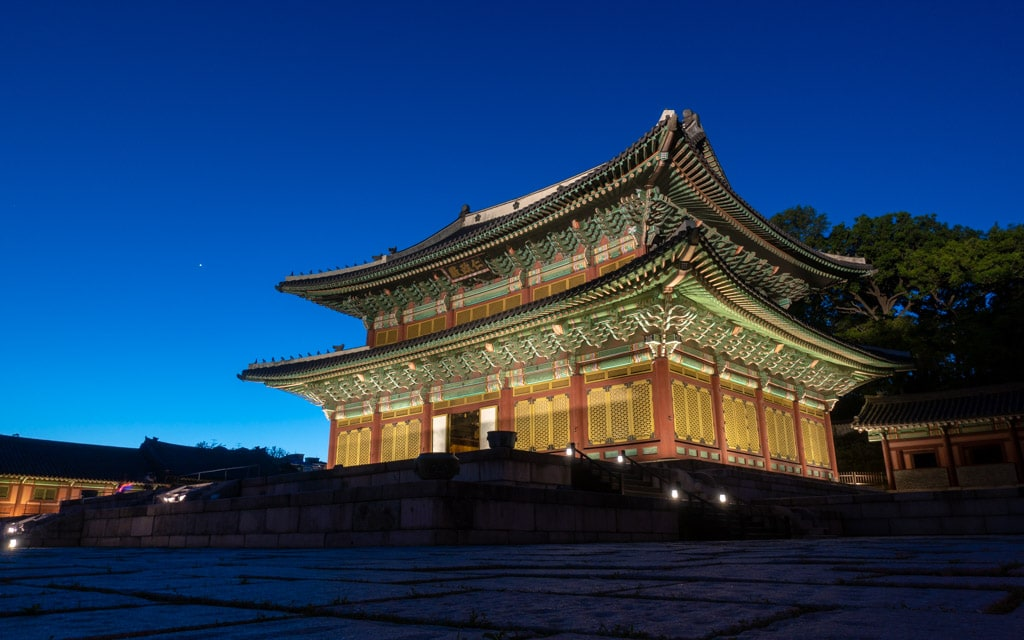Could you describe the architectural style featured in this image? The architectural style captured in the image is indicative of traditional Korean Joseon architecture. The building demonstrates the distinctive 'on-dol' heating and 'daecheong' cooling systems, which are innovative methods of environmental control suitable to the Korean climate. The style is characterized by colorful wooden structures with curvilinear roofs that rise at the corners, using natural materials that blend harmoniously with the surrounding landscape. Additionally, the intricate decorative paintings on the woodwork, known as 'dancheong', serve both an aesthetic and a practical purpose, protecting the wood and emphasizing its natural beauty. 